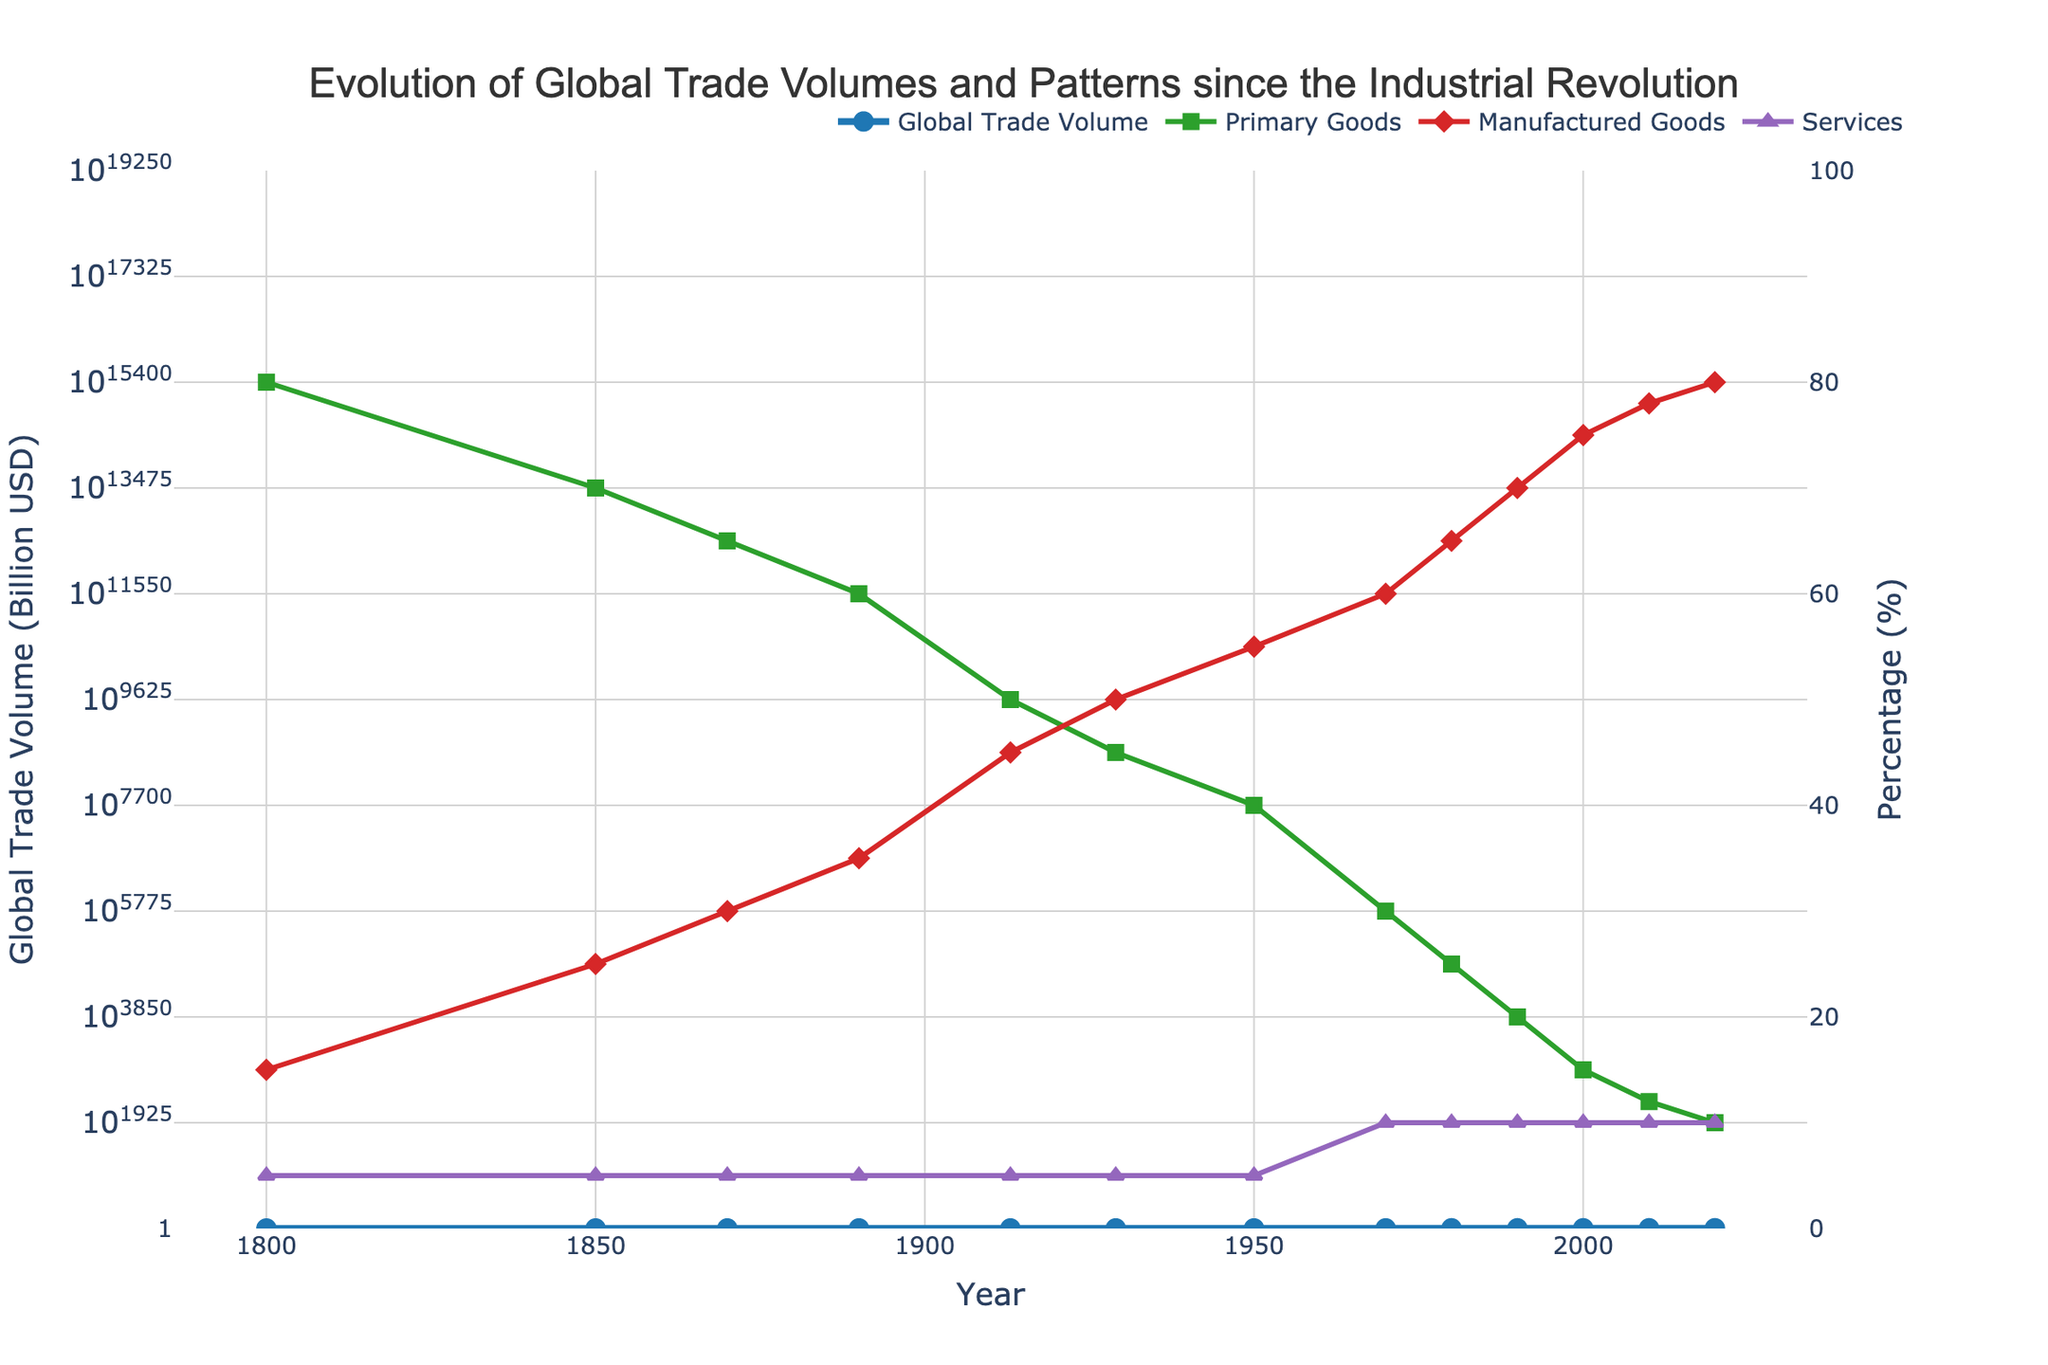What year saw the highest percentage of Primary Goods in global trade? First, locate the Primary Goods trace in green color. Follow it along the years to identify the highest point. It is at the beginning of the Y-axis.
Answer: 1800 When did Manufactured Goods surpass Primary Goods in percentage for the first time? Identify the red line for Manufactured Goods and the green line for Primary Goods. Determine the intersection point where the red line starts exceeding the green line.
Answer: 1913 How many times did the percentage of Services remain constant throughout the period shown? Follow the purple line for Services and count how many times it holds a steady value without change.
Answer: 7 By how much did the Global Trade Volume increase between 1950 and 2020? Locate the blue line for Global Trade Volume and note the values for 1950 and 2020. Subtract the 1950 value from the 2020 value: 17500 - 95 = 17405 billion USD.
Answer: 17405 billion USD Which decade saw the fastest growth in Global Trade Volume? Observe the blue line and assess the increase between each decade. The steepest slope indicates the fastest growth, which occurs between 1970 and 1980.
Answer: 1970-1980 What was the percentage difference between Manufactured Goods and Services in 2020? Check the values for Manufactured Goods and Services in 2020. Calculate the difference: 80% - 10% = 70%.
Answer: 70% Identify the year when Global Trade Volume reached 350 billion USD. Look at the blue line and find the year corresponding to 350 billion USD, which is 1970.
Answer: 1970 How did the percentage of Primary Goods change from 1800 to 2020? Note the percentage of Primary Goods in 1800 (80%) and 2020 (10%). Calculate the change: 80% - 10% = 70%.
Answer: Decreased by 70% In which year did the percentage of Services reach 10% for the first time? Follow the purple line for Services and spot the year where it first reaches 10%, which is 1970.
Answer: 1970 If you average the percentages of Primary Goods, Manufactured Goods, and Services in 2000, what is the result? Add the percentages in 2000: 15% + 75% + 10% = 100%. Divide by 3: 100/3 ≈ 33.33%.
Answer: 33.33% 